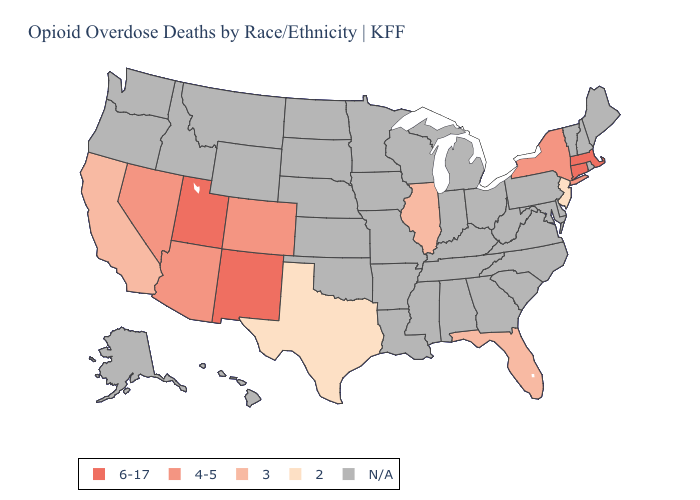Which states have the lowest value in the South?
Quick response, please. Texas. Name the states that have a value in the range N/A?
Answer briefly. Alabama, Alaska, Arkansas, Delaware, Georgia, Hawaii, Idaho, Indiana, Iowa, Kansas, Kentucky, Louisiana, Maine, Maryland, Michigan, Minnesota, Mississippi, Missouri, Montana, Nebraska, New Hampshire, North Carolina, North Dakota, Ohio, Oklahoma, Oregon, Pennsylvania, Rhode Island, South Carolina, South Dakota, Tennessee, Vermont, Virginia, Washington, West Virginia, Wisconsin, Wyoming. What is the value of Idaho?
Be succinct. N/A. What is the lowest value in states that border California?
Be succinct. 4-5. What is the highest value in the USA?
Write a very short answer. 6-17. Name the states that have a value in the range 4-5?
Concise answer only. Arizona, Colorado, Nevada, New York. What is the lowest value in the Northeast?
Quick response, please. 2. Among the states that border Utah , which have the lowest value?
Write a very short answer. Arizona, Colorado, Nevada. Does Florida have the lowest value in the South?
Keep it brief. No. Does the first symbol in the legend represent the smallest category?
Short answer required. No. What is the lowest value in states that border Texas?
Concise answer only. 6-17. Among the states that border Delaware , which have the lowest value?
Concise answer only. New Jersey. How many symbols are there in the legend?
Give a very brief answer. 5. What is the value of Missouri?
Concise answer only. N/A. 